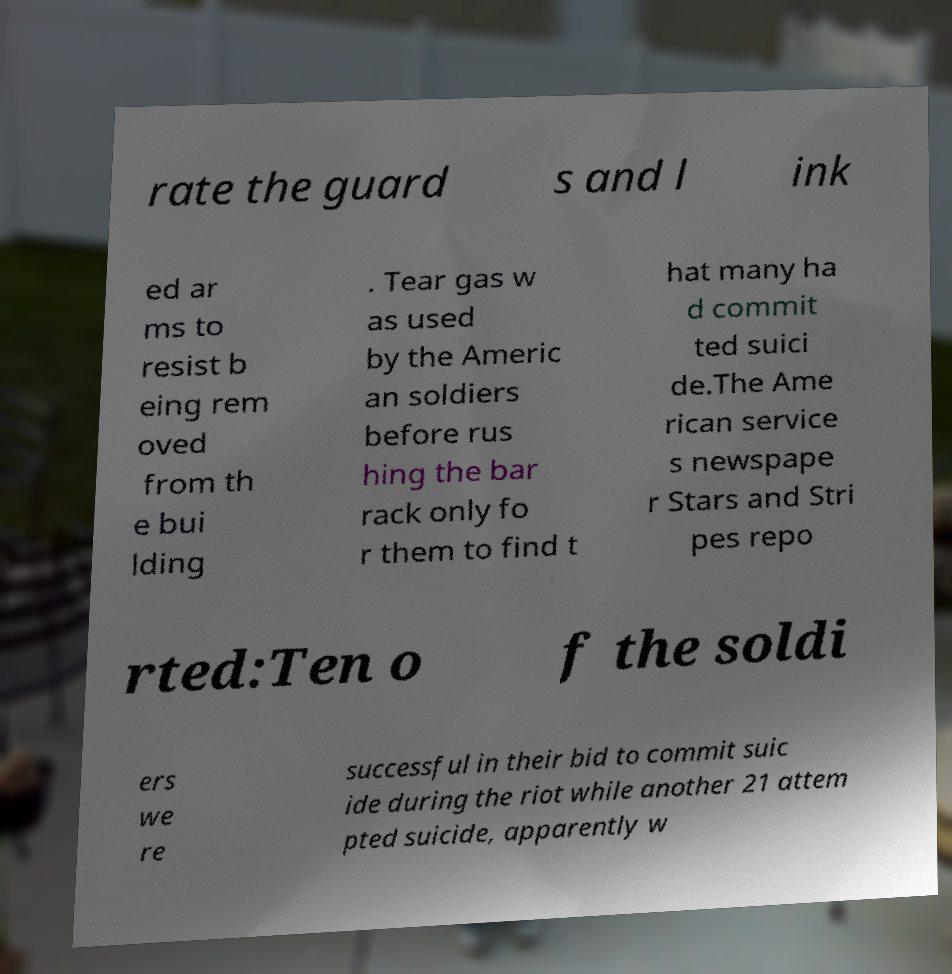Can you read and provide the text displayed in the image?This photo seems to have some interesting text. Can you extract and type it out for me? rate the guard s and l ink ed ar ms to resist b eing rem oved from th e bui lding . Tear gas w as used by the Americ an soldiers before rus hing the bar rack only fo r them to find t hat many ha d commit ted suici de.The Ame rican service s newspape r Stars and Stri pes repo rted:Ten o f the soldi ers we re successful in their bid to commit suic ide during the riot while another 21 attem pted suicide, apparently w 